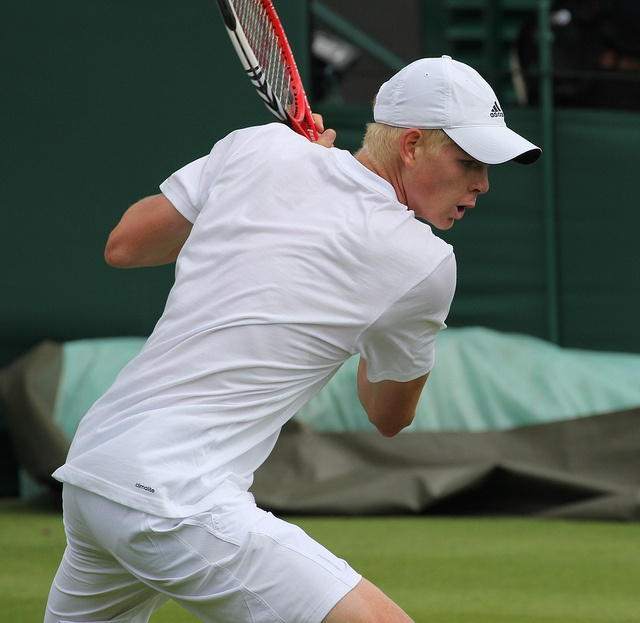Describe the objects in this image and their specific colors. I can see people in black, lavender, darkgray, and gray tones and tennis racket in black, gray, darkgray, and brown tones in this image. 